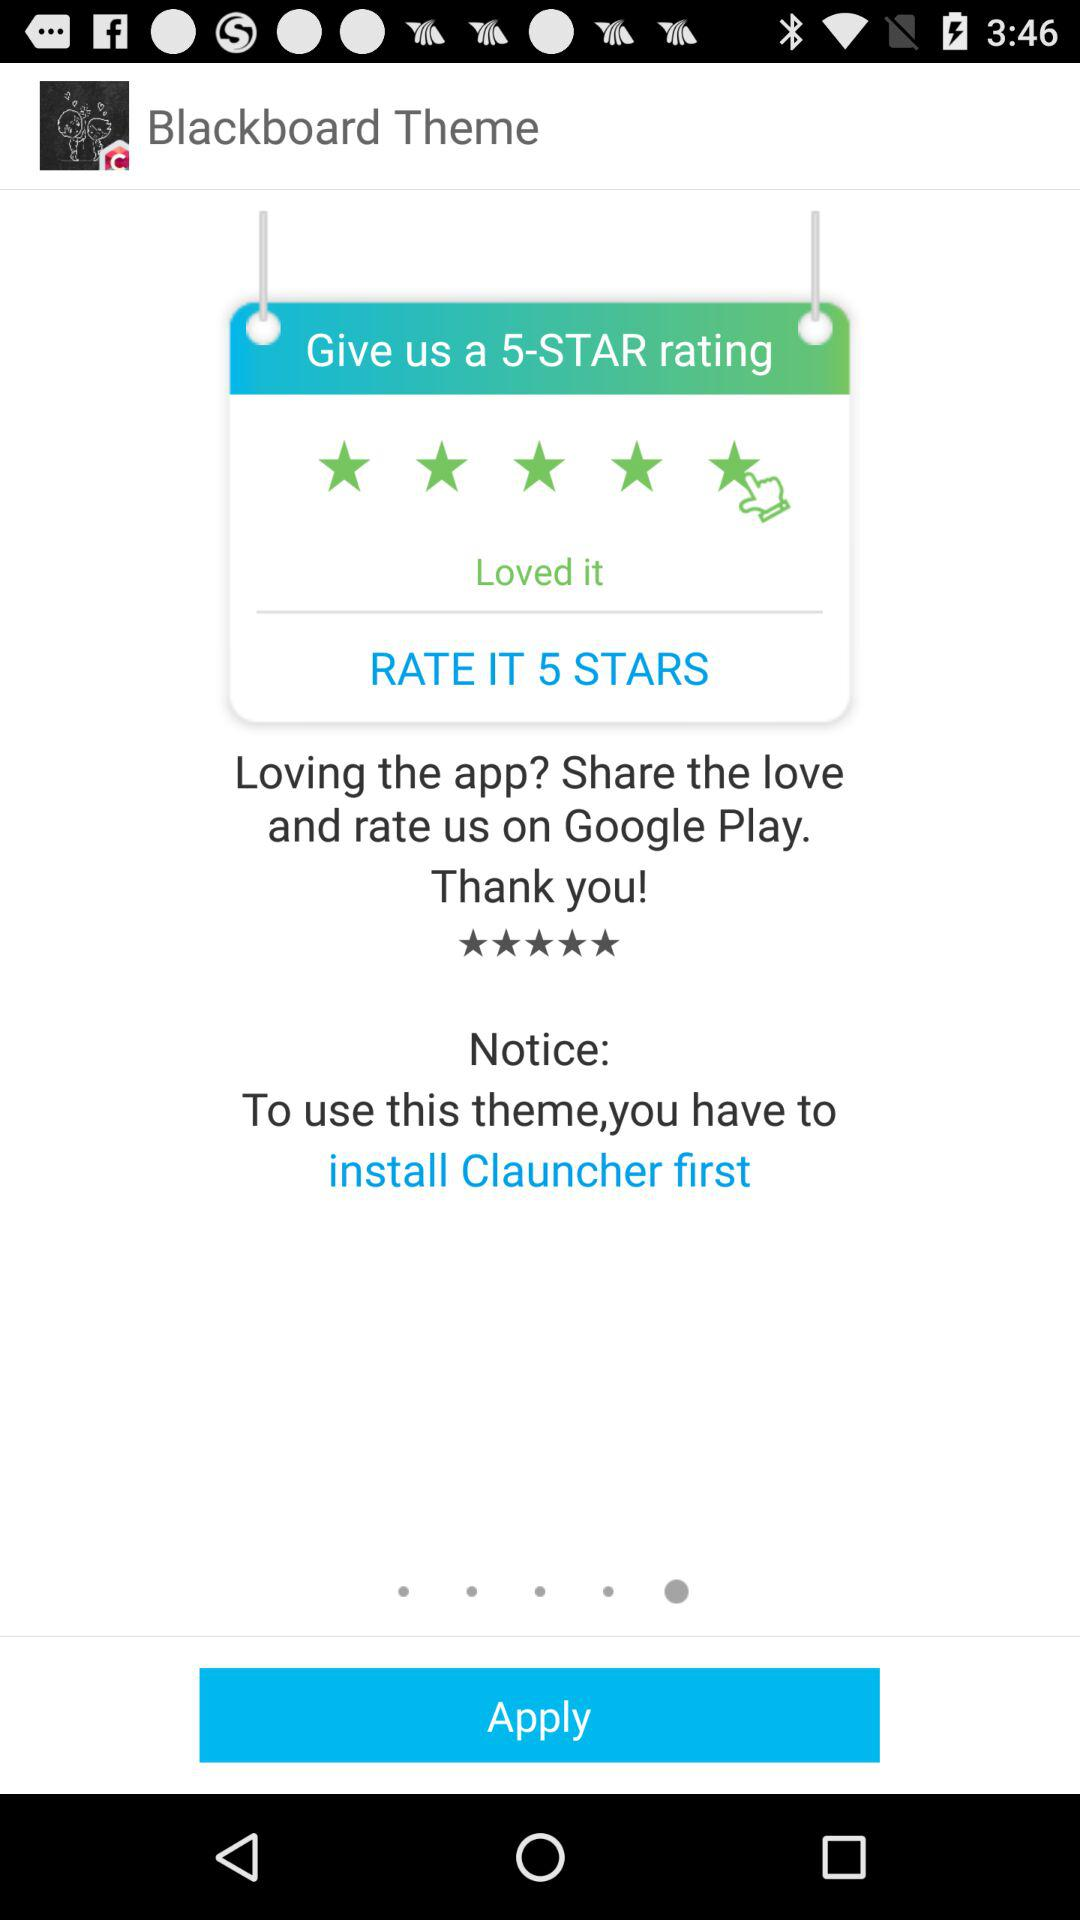What is the name of the theme? The name of the theme is "Blackboard". 